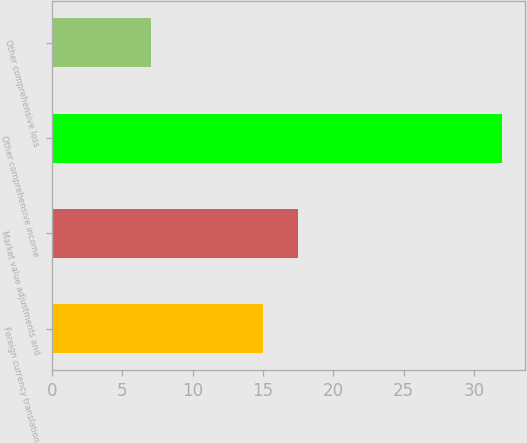Convert chart to OTSL. <chart><loc_0><loc_0><loc_500><loc_500><bar_chart><fcel>Foreign currency translation<fcel>Market value adjustments and<fcel>Other comprehensive income<fcel>Other comprehensive loss<nl><fcel>15<fcel>17.5<fcel>32<fcel>7<nl></chart> 